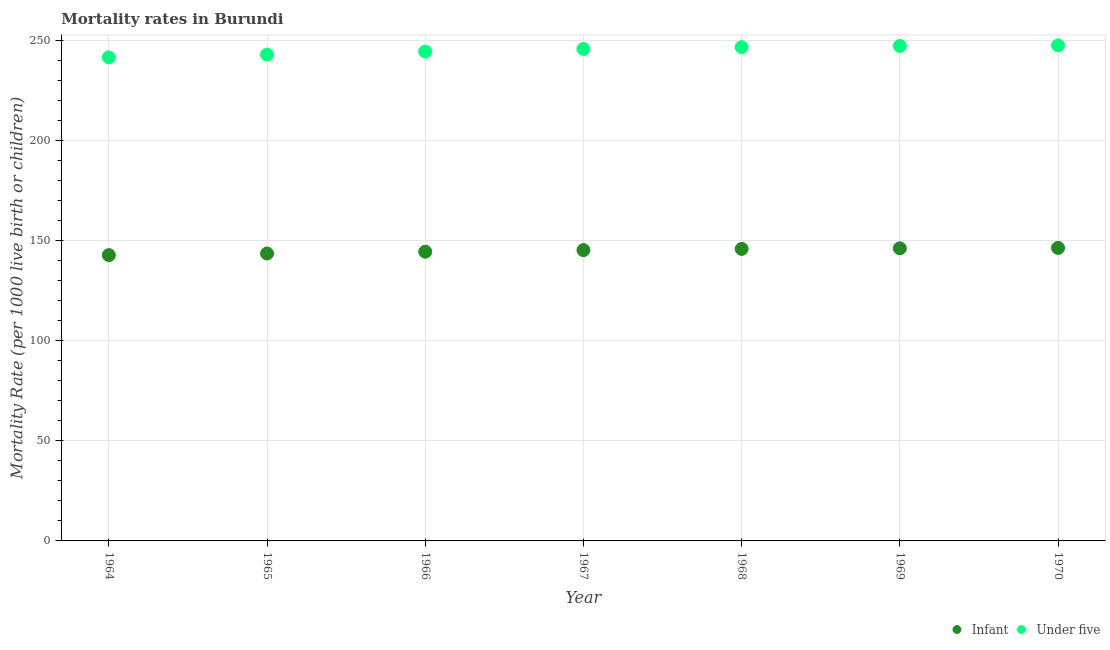What is the infant mortality rate in 1965?
Your response must be concise. 143.6. Across all years, what is the maximum under-5 mortality rate?
Offer a very short reply. 247.6. Across all years, what is the minimum under-5 mortality rate?
Ensure brevity in your answer.  241.6. In which year was the under-5 mortality rate maximum?
Your answer should be compact. 1970. In which year was the under-5 mortality rate minimum?
Ensure brevity in your answer.  1964. What is the total infant mortality rate in the graph?
Offer a terse response. 1014.7. What is the difference between the infant mortality rate in 1964 and that in 1969?
Provide a short and direct response. -3.4. What is the difference between the under-5 mortality rate in 1964 and the infant mortality rate in 1970?
Provide a short and direct response. 95.2. What is the average under-5 mortality rate per year?
Keep it short and to the point. 245.21. In the year 1964, what is the difference between the under-5 mortality rate and infant mortality rate?
Provide a short and direct response. 98.8. In how many years, is the infant mortality rate greater than 90?
Your answer should be very brief. 7. What is the ratio of the under-5 mortality rate in 1966 to that in 1969?
Your answer should be very brief. 0.99. Is the infant mortality rate in 1965 less than that in 1970?
Your response must be concise. Yes. What is the difference between the highest and the second highest under-5 mortality rate?
Provide a succinct answer. 0.3. What is the difference between the highest and the lowest under-5 mortality rate?
Offer a terse response. 6. In how many years, is the infant mortality rate greater than the average infant mortality rate taken over all years?
Provide a succinct answer. 4. Is the sum of the under-5 mortality rate in 1968 and 1969 greater than the maximum infant mortality rate across all years?
Provide a short and direct response. Yes. Does the infant mortality rate monotonically increase over the years?
Keep it short and to the point. Yes. Is the under-5 mortality rate strictly greater than the infant mortality rate over the years?
Ensure brevity in your answer.  Yes. Is the under-5 mortality rate strictly less than the infant mortality rate over the years?
Provide a short and direct response. No. How many dotlines are there?
Keep it short and to the point. 2. How many years are there in the graph?
Provide a succinct answer. 7. Are the values on the major ticks of Y-axis written in scientific E-notation?
Your answer should be compact. No. Where does the legend appear in the graph?
Ensure brevity in your answer.  Bottom right. How many legend labels are there?
Your response must be concise. 2. How are the legend labels stacked?
Ensure brevity in your answer.  Horizontal. What is the title of the graph?
Your answer should be compact. Mortality rates in Burundi. Does "Rural" appear as one of the legend labels in the graph?
Make the answer very short. No. What is the label or title of the X-axis?
Keep it short and to the point. Year. What is the label or title of the Y-axis?
Give a very brief answer. Mortality Rate (per 1000 live birth or children). What is the Mortality Rate (per 1000 live birth or children) of Infant in 1964?
Provide a short and direct response. 142.8. What is the Mortality Rate (per 1000 live birth or children) of Under five in 1964?
Your answer should be very brief. 241.6. What is the Mortality Rate (per 1000 live birth or children) in Infant in 1965?
Ensure brevity in your answer.  143.6. What is the Mortality Rate (per 1000 live birth or children) of Under five in 1965?
Keep it short and to the point. 243. What is the Mortality Rate (per 1000 live birth or children) of Infant in 1966?
Your answer should be very brief. 144.5. What is the Mortality Rate (per 1000 live birth or children) of Under five in 1966?
Offer a very short reply. 244.5. What is the Mortality Rate (per 1000 live birth or children) in Infant in 1967?
Offer a very short reply. 145.3. What is the Mortality Rate (per 1000 live birth or children) of Under five in 1967?
Ensure brevity in your answer.  245.8. What is the Mortality Rate (per 1000 live birth or children) in Infant in 1968?
Give a very brief answer. 145.9. What is the Mortality Rate (per 1000 live birth or children) of Under five in 1968?
Your response must be concise. 246.7. What is the Mortality Rate (per 1000 live birth or children) in Infant in 1969?
Keep it short and to the point. 146.2. What is the Mortality Rate (per 1000 live birth or children) of Under five in 1969?
Offer a terse response. 247.3. What is the Mortality Rate (per 1000 live birth or children) in Infant in 1970?
Your response must be concise. 146.4. What is the Mortality Rate (per 1000 live birth or children) of Under five in 1970?
Offer a terse response. 247.6. Across all years, what is the maximum Mortality Rate (per 1000 live birth or children) in Infant?
Give a very brief answer. 146.4. Across all years, what is the maximum Mortality Rate (per 1000 live birth or children) in Under five?
Your response must be concise. 247.6. Across all years, what is the minimum Mortality Rate (per 1000 live birth or children) in Infant?
Provide a short and direct response. 142.8. Across all years, what is the minimum Mortality Rate (per 1000 live birth or children) in Under five?
Ensure brevity in your answer.  241.6. What is the total Mortality Rate (per 1000 live birth or children) of Infant in the graph?
Keep it short and to the point. 1014.7. What is the total Mortality Rate (per 1000 live birth or children) in Under five in the graph?
Give a very brief answer. 1716.5. What is the difference between the Mortality Rate (per 1000 live birth or children) of Under five in 1964 and that in 1965?
Keep it short and to the point. -1.4. What is the difference between the Mortality Rate (per 1000 live birth or children) in Under five in 1964 and that in 1966?
Make the answer very short. -2.9. What is the difference between the Mortality Rate (per 1000 live birth or children) of Infant in 1964 and that in 1967?
Provide a short and direct response. -2.5. What is the difference between the Mortality Rate (per 1000 live birth or children) in Under five in 1964 and that in 1967?
Offer a terse response. -4.2. What is the difference between the Mortality Rate (per 1000 live birth or children) of Under five in 1964 and that in 1970?
Your answer should be compact. -6. What is the difference between the Mortality Rate (per 1000 live birth or children) of Infant in 1965 and that in 1966?
Ensure brevity in your answer.  -0.9. What is the difference between the Mortality Rate (per 1000 live birth or children) in Infant in 1965 and that in 1967?
Ensure brevity in your answer.  -1.7. What is the difference between the Mortality Rate (per 1000 live birth or children) of Infant in 1965 and that in 1969?
Make the answer very short. -2.6. What is the difference between the Mortality Rate (per 1000 live birth or children) of Infant in 1965 and that in 1970?
Give a very brief answer. -2.8. What is the difference between the Mortality Rate (per 1000 live birth or children) of Infant in 1966 and that in 1967?
Provide a short and direct response. -0.8. What is the difference between the Mortality Rate (per 1000 live birth or children) of Under five in 1966 and that in 1967?
Your answer should be very brief. -1.3. What is the difference between the Mortality Rate (per 1000 live birth or children) of Under five in 1966 and that in 1969?
Make the answer very short. -2.8. What is the difference between the Mortality Rate (per 1000 live birth or children) of Under five in 1966 and that in 1970?
Ensure brevity in your answer.  -3.1. What is the difference between the Mortality Rate (per 1000 live birth or children) of Infant in 1967 and that in 1968?
Provide a succinct answer. -0.6. What is the difference between the Mortality Rate (per 1000 live birth or children) of Under five in 1967 and that in 1968?
Keep it short and to the point. -0.9. What is the difference between the Mortality Rate (per 1000 live birth or children) of Infant in 1967 and that in 1969?
Give a very brief answer. -0.9. What is the difference between the Mortality Rate (per 1000 live birth or children) of Under five in 1967 and that in 1970?
Your response must be concise. -1.8. What is the difference between the Mortality Rate (per 1000 live birth or children) of Infant in 1968 and that in 1970?
Keep it short and to the point. -0.5. What is the difference between the Mortality Rate (per 1000 live birth or children) in Under five in 1968 and that in 1970?
Your response must be concise. -0.9. What is the difference between the Mortality Rate (per 1000 live birth or children) of Infant in 1969 and that in 1970?
Offer a terse response. -0.2. What is the difference between the Mortality Rate (per 1000 live birth or children) in Infant in 1964 and the Mortality Rate (per 1000 live birth or children) in Under five in 1965?
Provide a short and direct response. -100.2. What is the difference between the Mortality Rate (per 1000 live birth or children) in Infant in 1964 and the Mortality Rate (per 1000 live birth or children) in Under five in 1966?
Provide a succinct answer. -101.7. What is the difference between the Mortality Rate (per 1000 live birth or children) in Infant in 1964 and the Mortality Rate (per 1000 live birth or children) in Under five in 1967?
Give a very brief answer. -103. What is the difference between the Mortality Rate (per 1000 live birth or children) in Infant in 1964 and the Mortality Rate (per 1000 live birth or children) in Under five in 1968?
Make the answer very short. -103.9. What is the difference between the Mortality Rate (per 1000 live birth or children) in Infant in 1964 and the Mortality Rate (per 1000 live birth or children) in Under five in 1969?
Make the answer very short. -104.5. What is the difference between the Mortality Rate (per 1000 live birth or children) in Infant in 1964 and the Mortality Rate (per 1000 live birth or children) in Under five in 1970?
Make the answer very short. -104.8. What is the difference between the Mortality Rate (per 1000 live birth or children) in Infant in 1965 and the Mortality Rate (per 1000 live birth or children) in Under five in 1966?
Offer a terse response. -100.9. What is the difference between the Mortality Rate (per 1000 live birth or children) of Infant in 1965 and the Mortality Rate (per 1000 live birth or children) of Under five in 1967?
Your answer should be compact. -102.2. What is the difference between the Mortality Rate (per 1000 live birth or children) of Infant in 1965 and the Mortality Rate (per 1000 live birth or children) of Under five in 1968?
Offer a terse response. -103.1. What is the difference between the Mortality Rate (per 1000 live birth or children) in Infant in 1965 and the Mortality Rate (per 1000 live birth or children) in Under five in 1969?
Keep it short and to the point. -103.7. What is the difference between the Mortality Rate (per 1000 live birth or children) in Infant in 1965 and the Mortality Rate (per 1000 live birth or children) in Under five in 1970?
Your answer should be very brief. -104. What is the difference between the Mortality Rate (per 1000 live birth or children) in Infant in 1966 and the Mortality Rate (per 1000 live birth or children) in Under five in 1967?
Make the answer very short. -101.3. What is the difference between the Mortality Rate (per 1000 live birth or children) of Infant in 1966 and the Mortality Rate (per 1000 live birth or children) of Under five in 1968?
Your response must be concise. -102.2. What is the difference between the Mortality Rate (per 1000 live birth or children) in Infant in 1966 and the Mortality Rate (per 1000 live birth or children) in Under five in 1969?
Offer a very short reply. -102.8. What is the difference between the Mortality Rate (per 1000 live birth or children) in Infant in 1966 and the Mortality Rate (per 1000 live birth or children) in Under five in 1970?
Offer a very short reply. -103.1. What is the difference between the Mortality Rate (per 1000 live birth or children) in Infant in 1967 and the Mortality Rate (per 1000 live birth or children) in Under five in 1968?
Offer a terse response. -101.4. What is the difference between the Mortality Rate (per 1000 live birth or children) of Infant in 1967 and the Mortality Rate (per 1000 live birth or children) of Under five in 1969?
Offer a terse response. -102. What is the difference between the Mortality Rate (per 1000 live birth or children) of Infant in 1967 and the Mortality Rate (per 1000 live birth or children) of Under five in 1970?
Your answer should be compact. -102.3. What is the difference between the Mortality Rate (per 1000 live birth or children) of Infant in 1968 and the Mortality Rate (per 1000 live birth or children) of Under five in 1969?
Give a very brief answer. -101.4. What is the difference between the Mortality Rate (per 1000 live birth or children) in Infant in 1968 and the Mortality Rate (per 1000 live birth or children) in Under five in 1970?
Offer a very short reply. -101.7. What is the difference between the Mortality Rate (per 1000 live birth or children) in Infant in 1969 and the Mortality Rate (per 1000 live birth or children) in Under five in 1970?
Ensure brevity in your answer.  -101.4. What is the average Mortality Rate (per 1000 live birth or children) of Infant per year?
Provide a succinct answer. 144.96. What is the average Mortality Rate (per 1000 live birth or children) of Under five per year?
Offer a terse response. 245.21. In the year 1964, what is the difference between the Mortality Rate (per 1000 live birth or children) in Infant and Mortality Rate (per 1000 live birth or children) in Under five?
Give a very brief answer. -98.8. In the year 1965, what is the difference between the Mortality Rate (per 1000 live birth or children) in Infant and Mortality Rate (per 1000 live birth or children) in Under five?
Offer a very short reply. -99.4. In the year 1966, what is the difference between the Mortality Rate (per 1000 live birth or children) in Infant and Mortality Rate (per 1000 live birth or children) in Under five?
Ensure brevity in your answer.  -100. In the year 1967, what is the difference between the Mortality Rate (per 1000 live birth or children) in Infant and Mortality Rate (per 1000 live birth or children) in Under five?
Offer a very short reply. -100.5. In the year 1968, what is the difference between the Mortality Rate (per 1000 live birth or children) in Infant and Mortality Rate (per 1000 live birth or children) in Under five?
Your response must be concise. -100.8. In the year 1969, what is the difference between the Mortality Rate (per 1000 live birth or children) in Infant and Mortality Rate (per 1000 live birth or children) in Under five?
Provide a succinct answer. -101.1. In the year 1970, what is the difference between the Mortality Rate (per 1000 live birth or children) in Infant and Mortality Rate (per 1000 live birth or children) in Under five?
Ensure brevity in your answer.  -101.2. What is the ratio of the Mortality Rate (per 1000 live birth or children) in Under five in 1964 to that in 1965?
Your answer should be very brief. 0.99. What is the ratio of the Mortality Rate (per 1000 live birth or children) in Infant in 1964 to that in 1967?
Your response must be concise. 0.98. What is the ratio of the Mortality Rate (per 1000 live birth or children) of Under five in 1964 to that in 1967?
Provide a succinct answer. 0.98. What is the ratio of the Mortality Rate (per 1000 live birth or children) of Infant in 1964 to that in 1968?
Your answer should be compact. 0.98. What is the ratio of the Mortality Rate (per 1000 live birth or children) of Under five in 1964 to that in 1968?
Your answer should be compact. 0.98. What is the ratio of the Mortality Rate (per 1000 live birth or children) of Infant in 1964 to that in 1969?
Provide a succinct answer. 0.98. What is the ratio of the Mortality Rate (per 1000 live birth or children) in Under five in 1964 to that in 1969?
Give a very brief answer. 0.98. What is the ratio of the Mortality Rate (per 1000 live birth or children) in Infant in 1964 to that in 1970?
Offer a terse response. 0.98. What is the ratio of the Mortality Rate (per 1000 live birth or children) of Under five in 1964 to that in 1970?
Give a very brief answer. 0.98. What is the ratio of the Mortality Rate (per 1000 live birth or children) in Infant in 1965 to that in 1967?
Keep it short and to the point. 0.99. What is the ratio of the Mortality Rate (per 1000 live birth or children) in Under five in 1965 to that in 1967?
Keep it short and to the point. 0.99. What is the ratio of the Mortality Rate (per 1000 live birth or children) in Infant in 1965 to that in 1968?
Your response must be concise. 0.98. What is the ratio of the Mortality Rate (per 1000 live birth or children) of Under five in 1965 to that in 1968?
Ensure brevity in your answer.  0.98. What is the ratio of the Mortality Rate (per 1000 live birth or children) in Infant in 1965 to that in 1969?
Give a very brief answer. 0.98. What is the ratio of the Mortality Rate (per 1000 live birth or children) of Under five in 1965 to that in 1969?
Give a very brief answer. 0.98. What is the ratio of the Mortality Rate (per 1000 live birth or children) of Infant in 1965 to that in 1970?
Provide a short and direct response. 0.98. What is the ratio of the Mortality Rate (per 1000 live birth or children) in Under five in 1965 to that in 1970?
Your response must be concise. 0.98. What is the ratio of the Mortality Rate (per 1000 live birth or children) in Under five in 1966 to that in 1967?
Your answer should be very brief. 0.99. What is the ratio of the Mortality Rate (per 1000 live birth or children) in Infant in 1966 to that in 1969?
Your answer should be compact. 0.99. What is the ratio of the Mortality Rate (per 1000 live birth or children) in Under five in 1966 to that in 1969?
Keep it short and to the point. 0.99. What is the ratio of the Mortality Rate (per 1000 live birth or children) in Under five in 1966 to that in 1970?
Give a very brief answer. 0.99. What is the ratio of the Mortality Rate (per 1000 live birth or children) in Infant in 1967 to that in 1968?
Your answer should be very brief. 1. What is the ratio of the Mortality Rate (per 1000 live birth or children) of Infant in 1967 to that in 1969?
Provide a short and direct response. 0.99. What is the ratio of the Mortality Rate (per 1000 live birth or children) in Under five in 1967 to that in 1969?
Provide a short and direct response. 0.99. What is the ratio of the Mortality Rate (per 1000 live birth or children) of Infant in 1968 to that in 1969?
Offer a terse response. 1. What is the ratio of the Mortality Rate (per 1000 live birth or children) in Infant in 1968 to that in 1970?
Your answer should be very brief. 1. What is the ratio of the Mortality Rate (per 1000 live birth or children) in Infant in 1969 to that in 1970?
Keep it short and to the point. 1. What is the difference between the highest and the second highest Mortality Rate (per 1000 live birth or children) of Under five?
Keep it short and to the point. 0.3. What is the difference between the highest and the lowest Mortality Rate (per 1000 live birth or children) of Infant?
Provide a short and direct response. 3.6. 